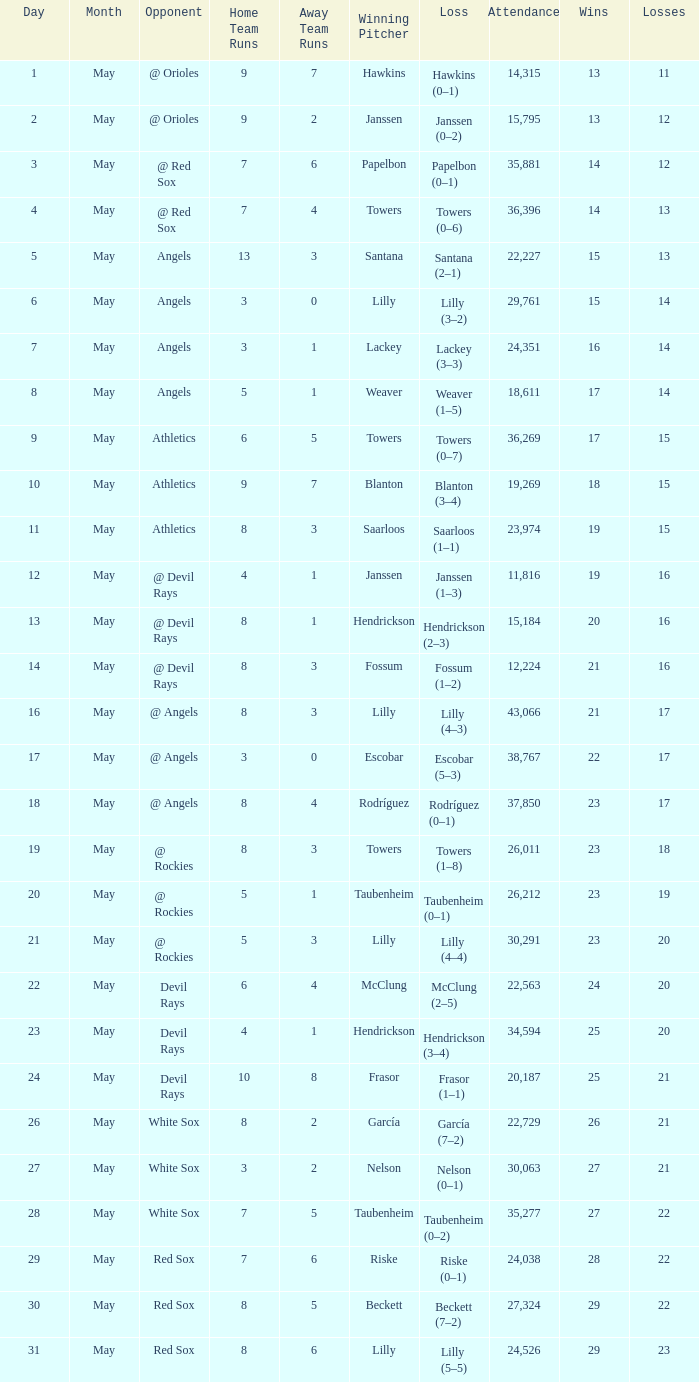Can you parse all the data within this table? {'header': ['Day', 'Month', 'Opponent', 'Home Team Runs', 'Away Team Runs', 'Winning Pitcher', 'Loss', 'Attendance', 'Wins', 'Losses'], 'rows': [['1', 'May', '@ Orioles', '9', '7', 'Hawkins', 'Hawkins (0–1)', '14,315', '13', '11'], ['2', 'May', '@ Orioles', '9', '2', 'Janssen', 'Janssen (0–2)', '15,795', '13', '12'], ['3', 'May', '@ Red Sox', '7', '6', 'Papelbon', 'Papelbon (0–1)', '35,881', '14', '12'], ['4', 'May', '@ Red Sox', '7', '4', 'Towers', 'Towers (0–6)', '36,396', '14', '13'], ['5', 'May', 'Angels', '13', '3', 'Santana', 'Santana (2–1)', '22,227', '15', '13'], ['6', 'May', 'Angels', '3', '0', 'Lilly', 'Lilly (3–2)', '29,761', '15', '14'], ['7', 'May', 'Angels', '3', '1', 'Lackey', 'Lackey (3–3)', '24,351', '16', '14'], ['8', 'May', 'Angels', '5', '1', 'Weaver', 'Weaver (1–5)', '18,611', '17', '14'], ['9', 'May', 'Athletics', '6', '5', 'Towers', 'Towers (0–7)', '36,269', '17', '15'], ['10', 'May', 'Athletics', '9', '7', 'Blanton', 'Blanton (3–4)', '19,269', '18', '15'], ['11', 'May', 'Athletics', '8', '3', 'Saarloos', 'Saarloos (1–1)', '23,974', '19', '15'], ['12', 'May', '@ Devil Rays', '4', '1', 'Janssen', 'Janssen (1–3)', '11,816', '19', '16'], ['13', 'May', '@ Devil Rays', '8', '1', 'Hendrickson', 'Hendrickson (2–3)', '15,184', '20', '16'], ['14', 'May', '@ Devil Rays', '8', '3', 'Fossum', 'Fossum (1–2)', '12,224', '21', '16'], ['16', 'May', '@ Angels', '8', '3', 'Lilly', 'Lilly (4–3)', '43,066', '21', '17'], ['17', 'May', '@ Angels', '3', '0', 'Escobar', 'Escobar (5–3)', '38,767', '22', '17'], ['18', 'May', '@ Angels', '8', '4', 'Rodríguez', 'Rodríguez (0–1)', '37,850', '23', '17'], ['19', 'May', '@ Rockies', '8', '3', 'Towers', 'Towers (1–8)', '26,011', '23', '18'], ['20', 'May', '@ Rockies', '5', '1', 'Taubenheim', 'Taubenheim (0–1)', '26,212', '23', '19'], ['21', 'May', '@ Rockies', '5', '3', 'Lilly', 'Lilly (4–4)', '30,291', '23', '20'], ['22', 'May', 'Devil Rays', '6', '4', 'McClung', 'McClung (2–5)', '22,563', '24', '20'], ['23', 'May', 'Devil Rays', '4', '1', 'Hendrickson', 'Hendrickson (3–4)', '34,594', '25', '20'], ['24', 'May', 'Devil Rays', '10', '8', 'Frasor', 'Frasor (1–1)', '20,187', '25', '21'], ['26', 'May', 'White Sox', '8', '2', 'García', 'García (7–2)', '22,729', '26', '21'], ['27', 'May', 'White Sox', '3', '2', 'Nelson', 'Nelson (0–1)', '30,063', '27', '21'], ['28', 'May', 'White Sox', '7', '5', 'Taubenheim', 'Taubenheim (0–2)', '35,277', '27', '22'], ['29', 'May', 'Red Sox', '7', '6', 'Riske', 'Riske (0–1)', '24,038', '28', '22'], ['30', 'May', 'Red Sox', '8', '5', 'Beckett', 'Beckett (7–2)', '27,324', '29', '22'], ['31', 'May', 'Red Sox', '8', '6', 'Lilly', 'Lilly (5–5)', '24,526', '29', '23']]} When the team had their record of 16–14, what was the total attendance? 1.0. 